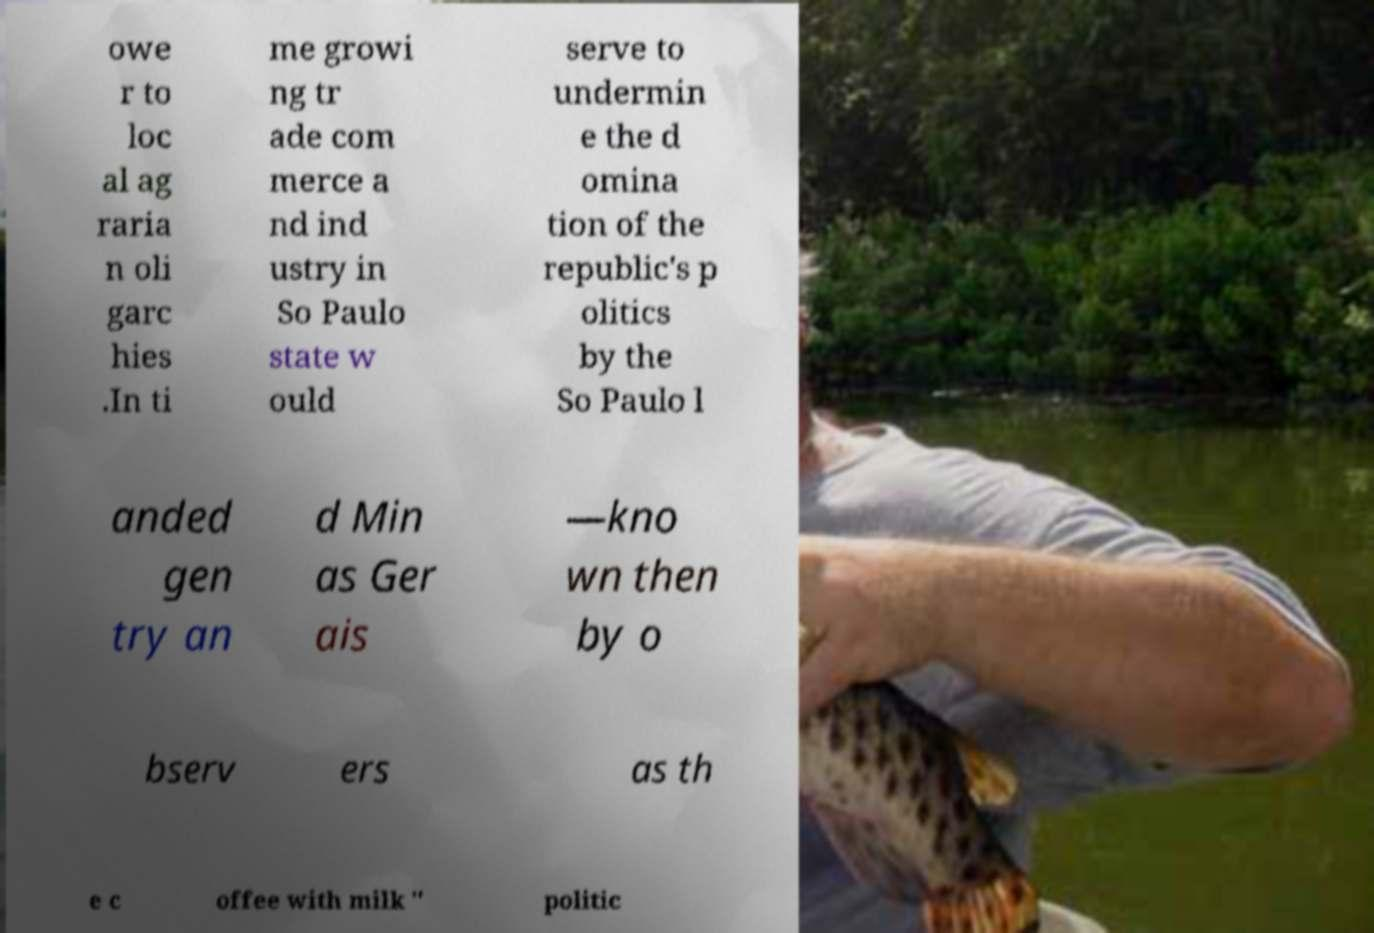What messages or text are displayed in this image? I need them in a readable, typed format. owe r to loc al ag raria n oli garc hies .In ti me growi ng tr ade com merce a nd ind ustry in So Paulo state w ould serve to undermin e the d omina tion of the republic's p olitics by the So Paulo l anded gen try an d Min as Ger ais —kno wn then by o bserv ers as th e c offee with milk " politic 